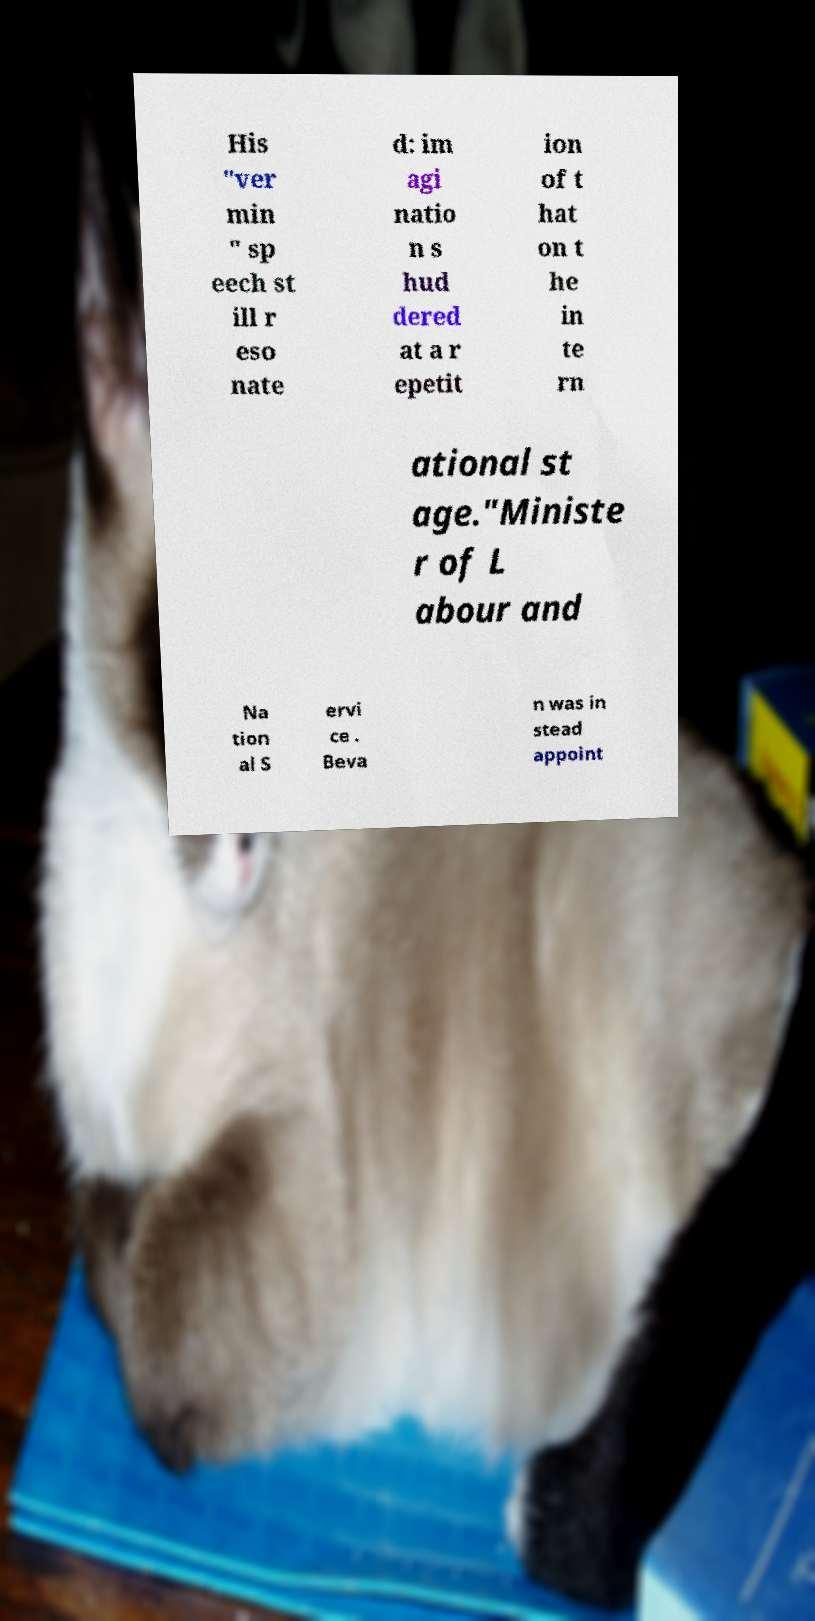What messages or text are displayed in this image? I need them in a readable, typed format. His "ver min " sp eech st ill r eso nate d: im agi natio n s hud dered at a r epetit ion of t hat on t he in te rn ational st age."Ministe r of L abour and Na tion al S ervi ce . Beva n was in stead appoint 